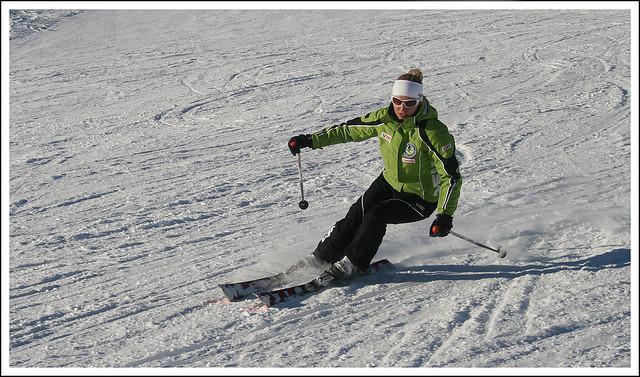How many clocks are showing?
Give a very brief answer. 0. 